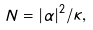Convert formula to latex. <formula><loc_0><loc_0><loc_500><loc_500>N = | \alpha | ^ { 2 } / \kappa ,</formula> 